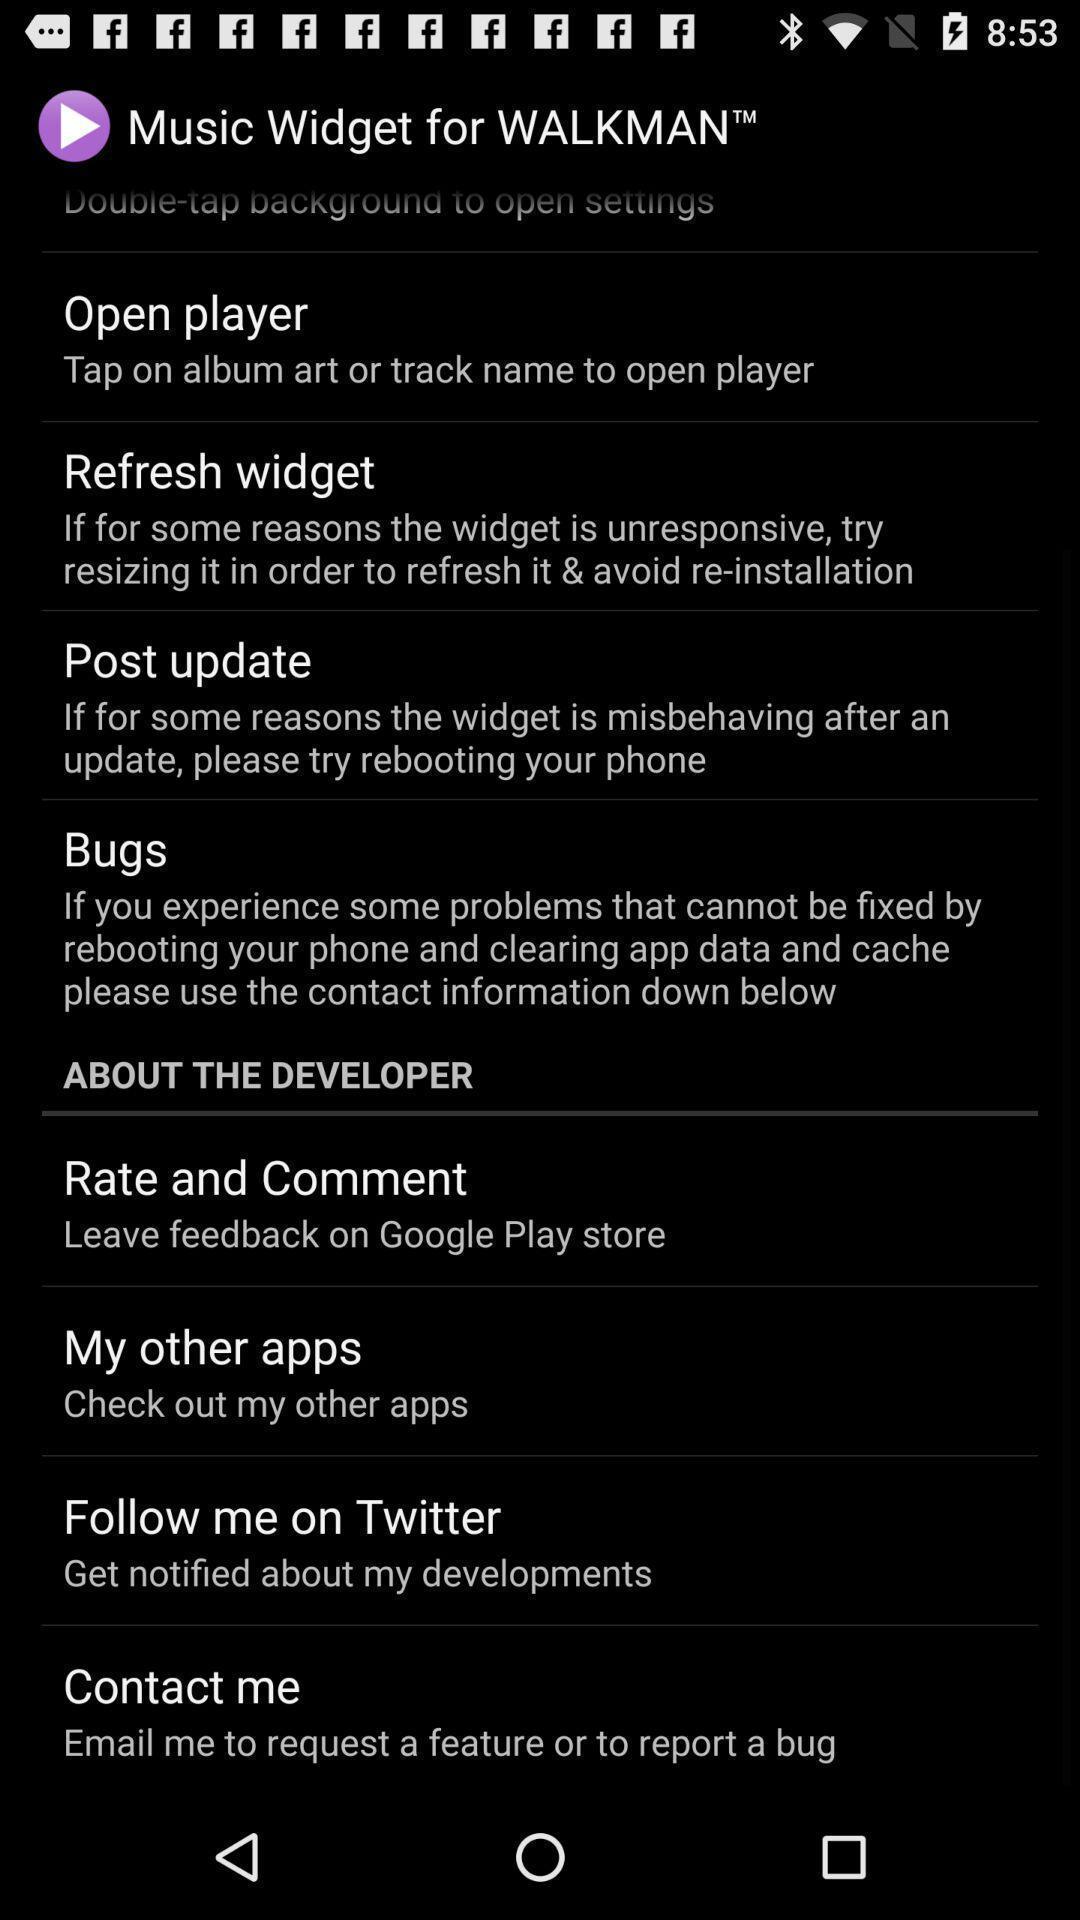Describe the content in this image. Page shows various setting options in the music app. 